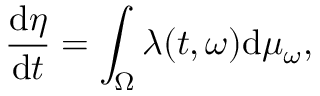<formula> <loc_0><loc_0><loc_500><loc_500>\frac { d \eta } { d t } = \int _ { \Omega } \lambda ( t , \omega ) d \mu _ { \omega } ,</formula> 